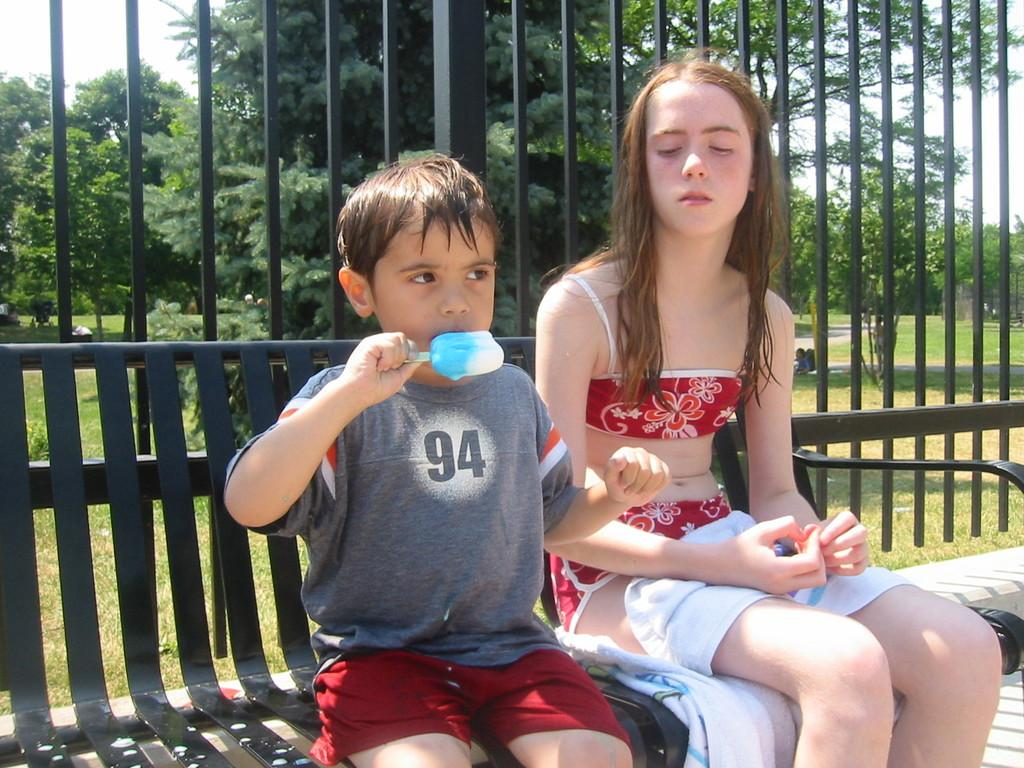Who are the people in the image? There is a girl and a boy in the image. What is the boy doing in the image? The boy is sitting on a bench and eating ice cream. What can be seen in the background of the image? There is a fence, trees, grass, and the sky visible in the background of the image. What language is the boy speaking in the image? The image does not provide any information about the language being spoken by the boy. Is the boy leading the girl to a specific location in the image? There is no indication in the image that the boy is leading the girl to a specific location. 